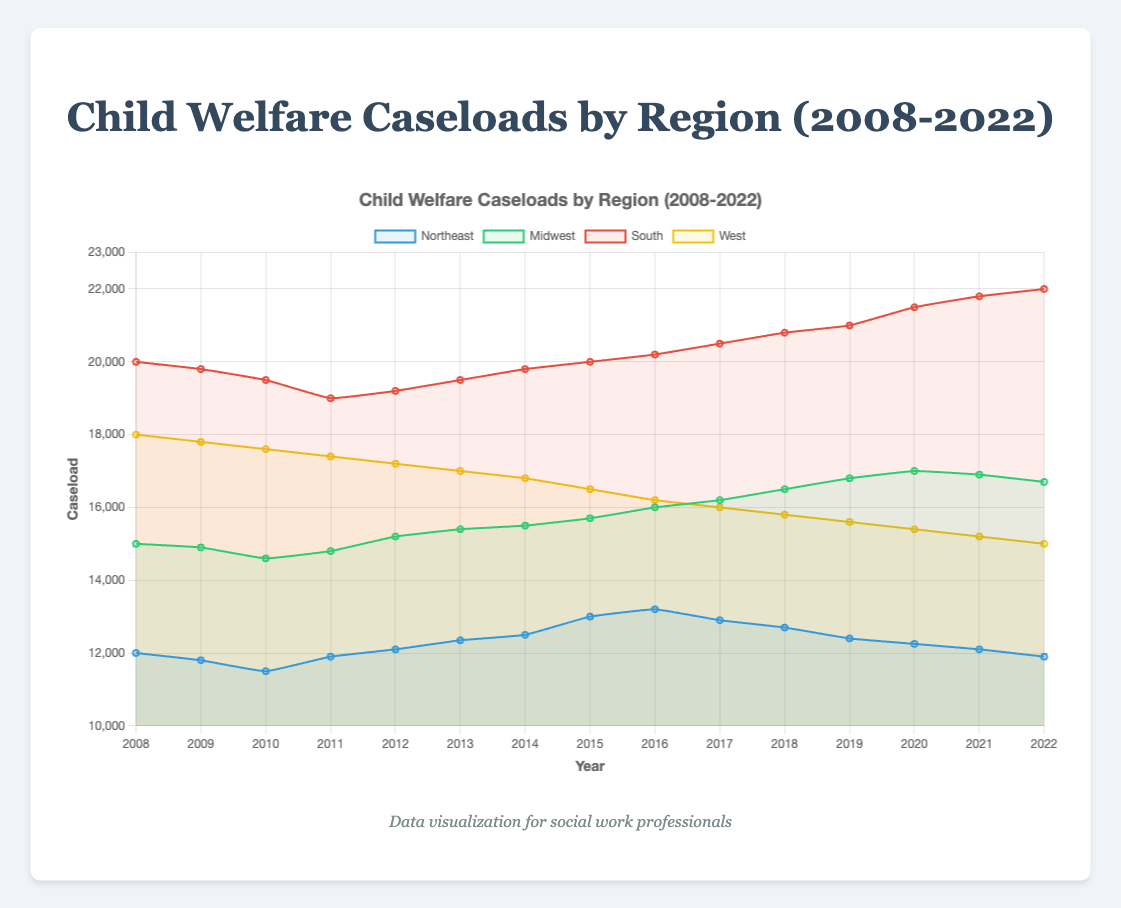What is the overall trend in child welfare caseloads in the Northeast from 2008 to 2022? The caseload in the Northeast generally decreases from 2008 to 2022, starting at 12000 in 2008 and ending at 11900 in 2022.
Answer: Decreasing trend Which region had the highest caseload in 2022? In 2022, the South had the highest caseload compared to other regions, with 22000 cases.
Answer: South By how much did the caseload change in the Midwest between the years 2010 and 2020? The caseload in the Midwest in 2010 was 14600, and in 2020 it was 17000. The change is 17000 - 14600 = 2400.
Answer: 2400 Which region had the steepest decline in caseloads over the 15 years? The West had the steepest decline, going from 18000 in 2008 to 15000 in 2022, a total decrease of 3000 cases.
Answer: West Compare the caseloads between the Northeast and the Midwest in 2015. Which region had more cases, and by how much? In 2015, the Northeast had 13000 cases, while the Midwest had 15700. The Midwest had more cases by 15700 - 13000 = 2700.
Answer: Midwest by 2700 What was the average caseload in the South from 2008 to 2022? Sum the South's caseloads for all years from 2008 to 2022 (20000 + 19800 + 19500 + 19000 + 19200 + 19500 + 19800 + 20000 + 20200 + 20500 + 20800 + 21000 + 21500 + 21800 + 22000 = 320800). Divide by the number of years (320800 / 15).
Answer: 21386.67 Identify any years where the caseload in the Northeast increased from the previous year. The Northeast caseload increased in 2011 (from 11800 to 11900), 2012 (from 11900 to 12100), 2013 (from 12100 to 12350), 2014 (from 12350 to 12500), 2015 (from 12500 to 13000), and 2016 (from 13000 to 13200).
Answer: 2011, 2012, 2013, 2014, 2015, 2016 By how much did the caseload in the South increase from 2019 to 2022? The caseload in the South was 21000 in 2019 and 22000 in 2022. The increase is 22000 - 21000 = 1000.
Answer: 1000 Compare the caseloads in the West in 2008 and 2022. What is the percent decrease over these years? The caseload in the West was 18000 in 2008 and 15000 in 2022. The percent decrease is ((18000 - 15000) / 18000) * 100, which is approximately 16.67%.
Answer: 16.67% Which region had a nearly constant increase in caseloads from 2008 to 2022? The South showed a nearly constant increase in caseloads over the years, rising steadily every year from 2008 to 2022.
Answer: South 